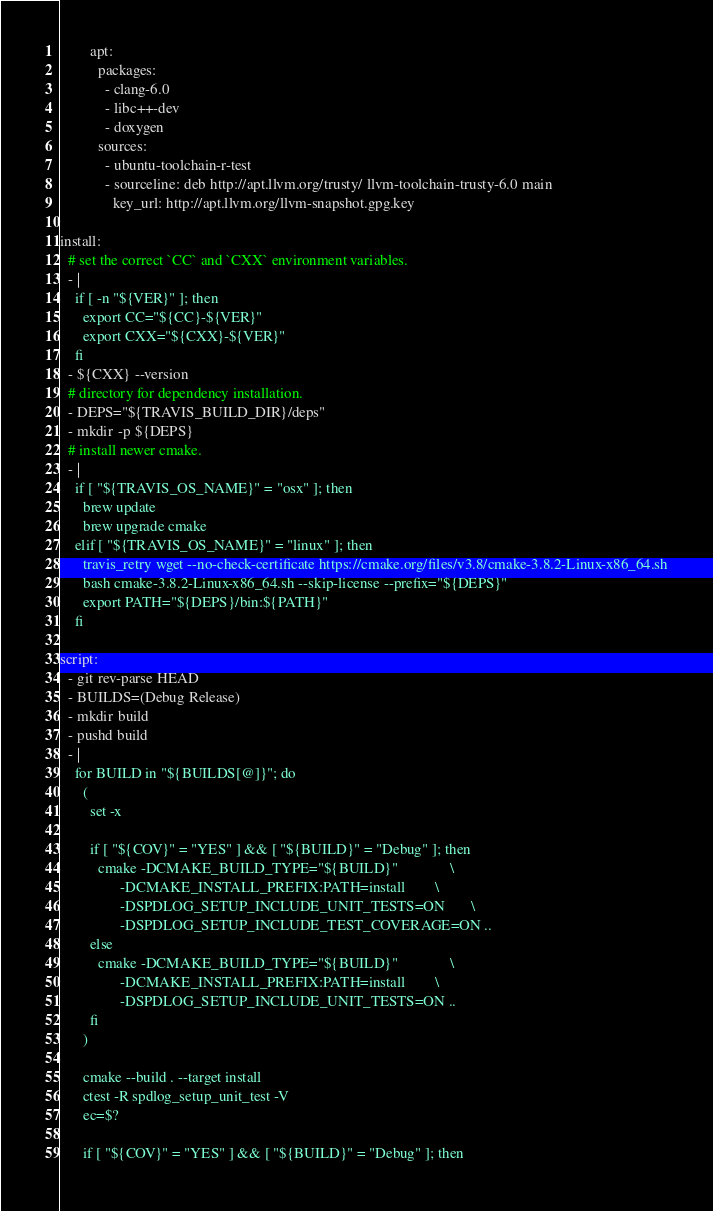Convert code to text. <code><loc_0><loc_0><loc_500><loc_500><_YAML_>        apt:
          packages:
            - clang-6.0
            - libc++-dev
            - doxygen
          sources:
            - ubuntu-toolchain-r-test
            - sourceline: deb http://apt.llvm.org/trusty/ llvm-toolchain-trusty-6.0 main
              key_url: http://apt.llvm.org/llvm-snapshot.gpg.key

install:
  # set the correct `CC` and `CXX` environment variables.
  - |
    if [ -n "${VER}" ]; then
      export CC="${CC}-${VER}"
      export CXX="${CXX}-${VER}"
    fi
  - ${CXX} --version
  # directory for dependency installation.
  - DEPS="${TRAVIS_BUILD_DIR}/deps"
  - mkdir -p ${DEPS}
  # install newer cmake.
  - |
    if [ "${TRAVIS_OS_NAME}" = "osx" ]; then
      brew update
      brew upgrade cmake
    elif [ "${TRAVIS_OS_NAME}" = "linux" ]; then
      travis_retry wget --no-check-certificate https://cmake.org/files/v3.8/cmake-3.8.2-Linux-x86_64.sh
      bash cmake-3.8.2-Linux-x86_64.sh --skip-license --prefix="${DEPS}"
      export PATH="${DEPS}/bin:${PATH}"
    fi

script:
  - git rev-parse HEAD
  - BUILDS=(Debug Release)
  - mkdir build
  - pushd build
  - |
    for BUILD in "${BUILDS[@]}"; do
      (
        set -x

        if [ "${COV}" = "YES" ] && [ "${BUILD}" = "Debug" ]; then
          cmake -DCMAKE_BUILD_TYPE="${BUILD}"              \
                -DCMAKE_INSTALL_PREFIX:PATH=install        \
                -DSPDLOG_SETUP_INCLUDE_UNIT_TESTS=ON       \
                -DSPDLOG_SETUP_INCLUDE_TEST_COVERAGE=ON ..
        else
          cmake -DCMAKE_BUILD_TYPE="${BUILD}"              \
                -DCMAKE_INSTALL_PREFIX:PATH=install        \
                -DSPDLOG_SETUP_INCLUDE_UNIT_TESTS=ON ..
        fi
      )

      cmake --build . --target install
      ctest -R spdlog_setup_unit_test -V
      ec=$?

      if [ "${COV}" = "YES" ] && [ "${BUILD}" = "Debug" ]; then</code> 